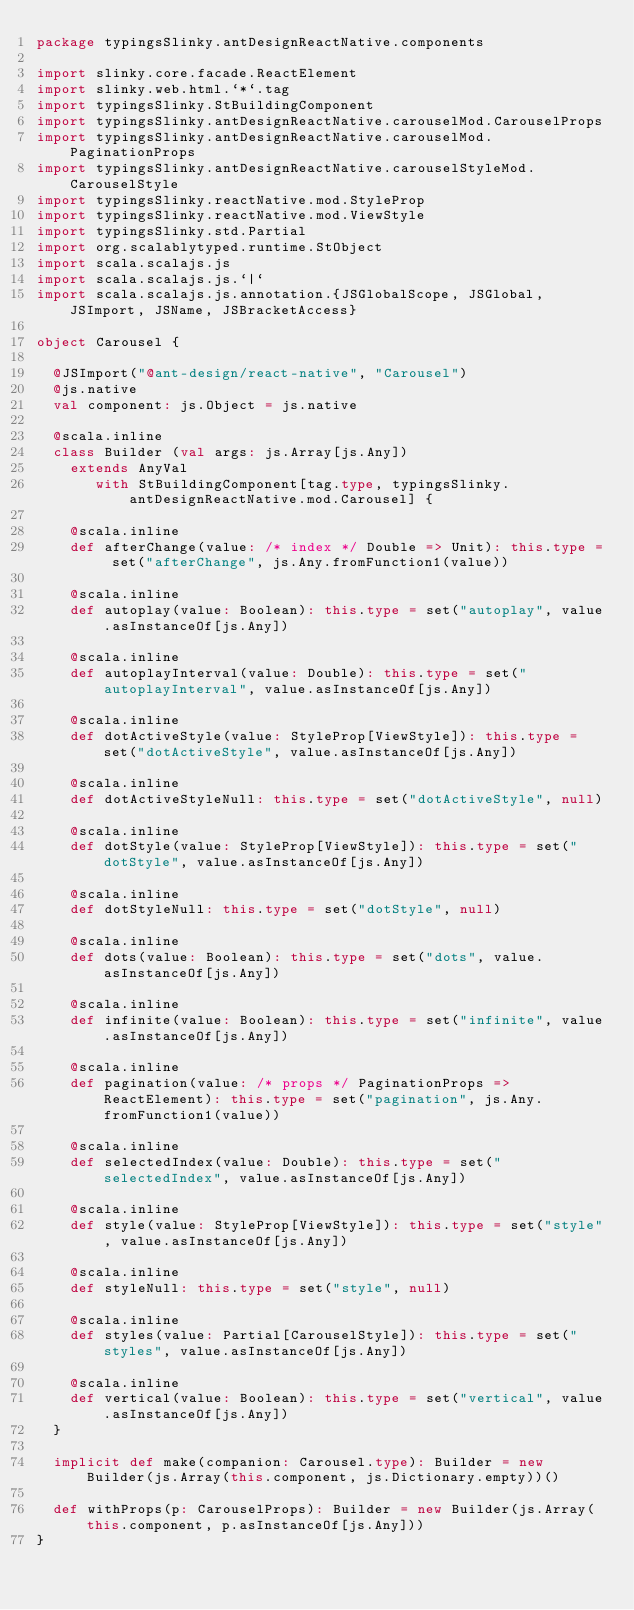Convert code to text. <code><loc_0><loc_0><loc_500><loc_500><_Scala_>package typingsSlinky.antDesignReactNative.components

import slinky.core.facade.ReactElement
import slinky.web.html.`*`.tag
import typingsSlinky.StBuildingComponent
import typingsSlinky.antDesignReactNative.carouselMod.CarouselProps
import typingsSlinky.antDesignReactNative.carouselMod.PaginationProps
import typingsSlinky.antDesignReactNative.carouselStyleMod.CarouselStyle
import typingsSlinky.reactNative.mod.StyleProp
import typingsSlinky.reactNative.mod.ViewStyle
import typingsSlinky.std.Partial
import org.scalablytyped.runtime.StObject
import scala.scalajs.js
import scala.scalajs.js.`|`
import scala.scalajs.js.annotation.{JSGlobalScope, JSGlobal, JSImport, JSName, JSBracketAccess}

object Carousel {
  
  @JSImport("@ant-design/react-native", "Carousel")
  @js.native
  val component: js.Object = js.native
  
  @scala.inline
  class Builder (val args: js.Array[js.Any])
    extends AnyVal
       with StBuildingComponent[tag.type, typingsSlinky.antDesignReactNative.mod.Carousel] {
    
    @scala.inline
    def afterChange(value: /* index */ Double => Unit): this.type = set("afterChange", js.Any.fromFunction1(value))
    
    @scala.inline
    def autoplay(value: Boolean): this.type = set("autoplay", value.asInstanceOf[js.Any])
    
    @scala.inline
    def autoplayInterval(value: Double): this.type = set("autoplayInterval", value.asInstanceOf[js.Any])
    
    @scala.inline
    def dotActiveStyle(value: StyleProp[ViewStyle]): this.type = set("dotActiveStyle", value.asInstanceOf[js.Any])
    
    @scala.inline
    def dotActiveStyleNull: this.type = set("dotActiveStyle", null)
    
    @scala.inline
    def dotStyle(value: StyleProp[ViewStyle]): this.type = set("dotStyle", value.asInstanceOf[js.Any])
    
    @scala.inline
    def dotStyleNull: this.type = set("dotStyle", null)
    
    @scala.inline
    def dots(value: Boolean): this.type = set("dots", value.asInstanceOf[js.Any])
    
    @scala.inline
    def infinite(value: Boolean): this.type = set("infinite", value.asInstanceOf[js.Any])
    
    @scala.inline
    def pagination(value: /* props */ PaginationProps => ReactElement): this.type = set("pagination", js.Any.fromFunction1(value))
    
    @scala.inline
    def selectedIndex(value: Double): this.type = set("selectedIndex", value.asInstanceOf[js.Any])
    
    @scala.inline
    def style(value: StyleProp[ViewStyle]): this.type = set("style", value.asInstanceOf[js.Any])
    
    @scala.inline
    def styleNull: this.type = set("style", null)
    
    @scala.inline
    def styles(value: Partial[CarouselStyle]): this.type = set("styles", value.asInstanceOf[js.Any])
    
    @scala.inline
    def vertical(value: Boolean): this.type = set("vertical", value.asInstanceOf[js.Any])
  }
  
  implicit def make(companion: Carousel.type): Builder = new Builder(js.Array(this.component, js.Dictionary.empty))()
  
  def withProps(p: CarouselProps): Builder = new Builder(js.Array(this.component, p.asInstanceOf[js.Any]))
}
</code> 